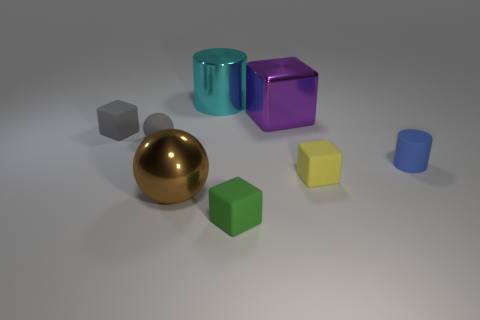Subtract all tiny rubber cubes. How many cubes are left? 1 Add 1 tiny rubber cylinders. How many objects exist? 9 Subtract all cyan cylinders. How many cylinders are left? 1 Subtract all cylinders. How many objects are left? 6 Subtract 1 spheres. How many spheres are left? 1 Subtract all purple spheres. Subtract all cyan cubes. How many spheres are left? 2 Subtract all small cyan rubber objects. Subtract all tiny green rubber objects. How many objects are left? 7 Add 8 large cyan things. How many large cyan things are left? 9 Add 7 large cyan metal objects. How many large cyan metal objects exist? 8 Subtract 0 blue blocks. How many objects are left? 8 